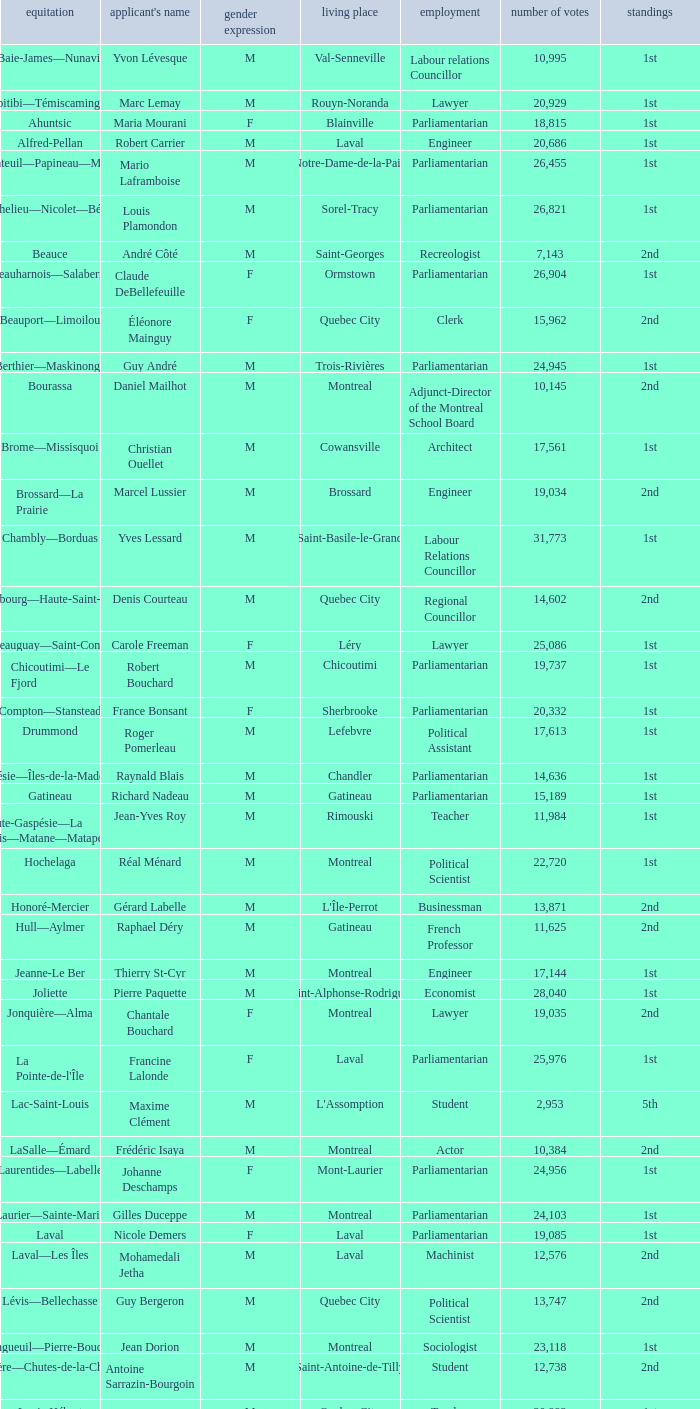What is the highest number of votes for the French Professor? 11625.0. 